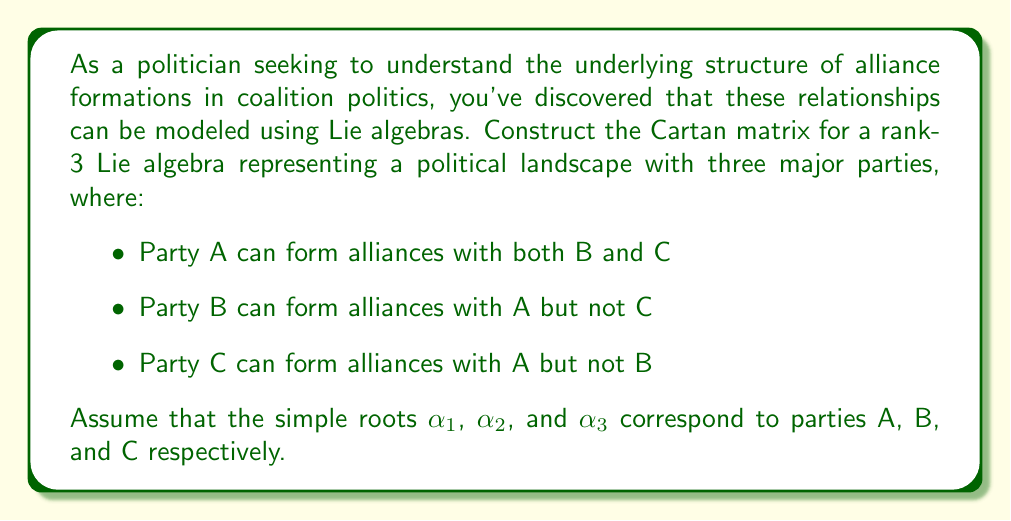Can you solve this math problem? To construct the Cartan matrix for this Lie algebra, we need to consider the relationships between the simple roots corresponding to each party. The Cartan matrix $A=(a_{ij})$ for a rank-n Lie algebra is an n×n matrix where:

1. $a_{ii} = 2$ for all i
2. $a_{ij} \leq 0$ for i ≠ j
3. $a_{ij} = 0$ if and only if $a_{ji} = 0$
4. $a_{ij}$ are integers

For our political scenario:

1. $(\alpha_1, \alpha_1) = (\alpha_2, \alpha_2) = (\alpha_3, \alpha_3) = 2$ (diagonal elements)

2. Party A (α₁) can form alliances with B (α₂) and C (α₃):
   $a_{12} = a_{21} = -1$ and $a_{13} = a_{31} = -1$

3. Party B (α₂) cannot form an alliance with C (α₃):
   $a_{23} = a_{32} = 0$

Therefore, the Cartan matrix A is:

$$A = \begin{pmatrix}
2 & -1 & -1 \\
-1 & 2 & 0 \\
-1 & 0 & 2
\end{pmatrix}$$

This matrix represents the $A_1 \times A_2$ Lie algebra, which corresponds to the direct sum of the $\mathfrak{sl}(2)$ and $\mathfrak{sl}(3)$ Lie algebras.
Answer: $$A = \begin{pmatrix}
2 & -1 & -1 \\
-1 & 2 & 0 \\
-1 & 0 & 2
\end{pmatrix}$$ 